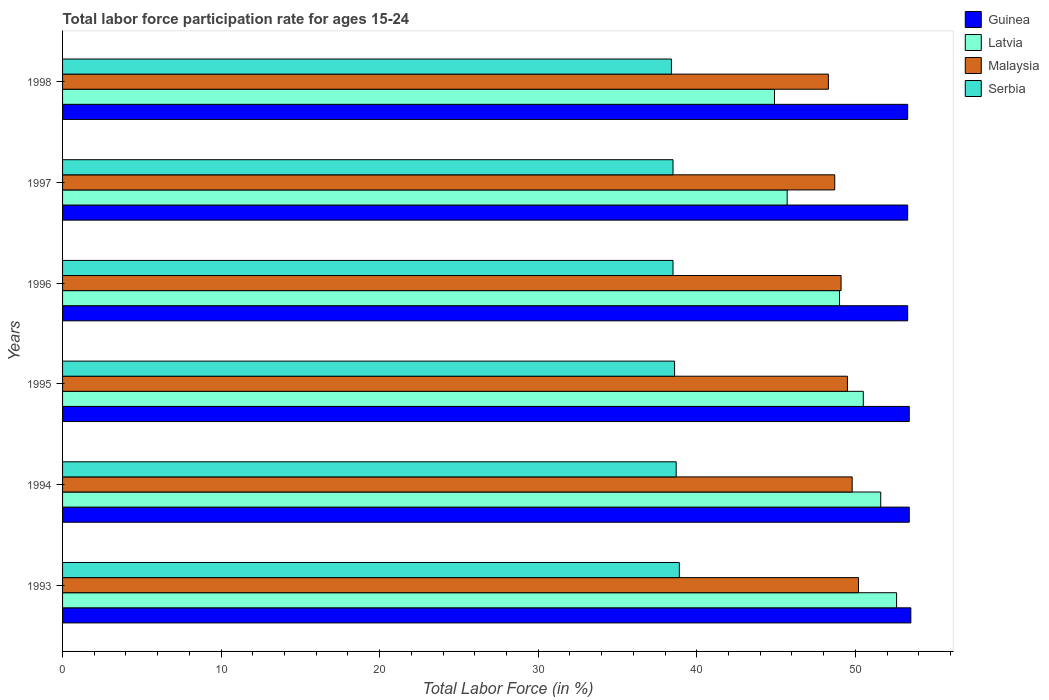How many different coloured bars are there?
Ensure brevity in your answer.  4. How many groups of bars are there?
Keep it short and to the point. 6. Are the number of bars per tick equal to the number of legend labels?
Your answer should be compact. Yes. What is the labor force participation rate in Malaysia in 1994?
Provide a succinct answer. 49.8. Across all years, what is the maximum labor force participation rate in Latvia?
Keep it short and to the point. 52.6. Across all years, what is the minimum labor force participation rate in Latvia?
Offer a terse response. 44.9. In which year was the labor force participation rate in Serbia maximum?
Offer a very short reply. 1993. What is the total labor force participation rate in Guinea in the graph?
Keep it short and to the point. 320.2. What is the difference between the labor force participation rate in Malaysia in 1993 and that in 1995?
Provide a short and direct response. 0.7. What is the difference between the labor force participation rate in Latvia in 1993 and the labor force participation rate in Serbia in 1996?
Make the answer very short. 14.1. What is the average labor force participation rate in Malaysia per year?
Provide a succinct answer. 49.27. In the year 1993, what is the difference between the labor force participation rate in Guinea and labor force participation rate in Latvia?
Your answer should be compact. 0.9. In how many years, is the labor force participation rate in Malaysia greater than 32 %?
Provide a succinct answer. 6. What is the ratio of the labor force participation rate in Malaysia in 1996 to that in 1997?
Keep it short and to the point. 1.01. Is the labor force participation rate in Serbia in 1994 less than that in 1996?
Your answer should be very brief. No. What is the difference between the highest and the second highest labor force participation rate in Guinea?
Provide a succinct answer. 0.1. What is the difference between the highest and the lowest labor force participation rate in Guinea?
Your response must be concise. 0.2. Is the sum of the labor force participation rate in Malaysia in 1995 and 1997 greater than the maximum labor force participation rate in Latvia across all years?
Offer a terse response. Yes. What does the 4th bar from the top in 1997 represents?
Provide a succinct answer. Guinea. What does the 1st bar from the bottom in 1996 represents?
Provide a short and direct response. Guinea. Is it the case that in every year, the sum of the labor force participation rate in Malaysia and labor force participation rate in Serbia is greater than the labor force participation rate in Guinea?
Provide a succinct answer. Yes. How many bars are there?
Your answer should be compact. 24. How many years are there in the graph?
Provide a succinct answer. 6. How many legend labels are there?
Provide a succinct answer. 4. How are the legend labels stacked?
Offer a very short reply. Vertical. What is the title of the graph?
Provide a succinct answer. Total labor force participation rate for ages 15-24. Does "Afghanistan" appear as one of the legend labels in the graph?
Your response must be concise. No. What is the label or title of the Y-axis?
Provide a short and direct response. Years. What is the Total Labor Force (in %) in Guinea in 1993?
Your answer should be compact. 53.5. What is the Total Labor Force (in %) of Latvia in 1993?
Keep it short and to the point. 52.6. What is the Total Labor Force (in %) in Malaysia in 1993?
Your response must be concise. 50.2. What is the Total Labor Force (in %) of Serbia in 1993?
Your answer should be very brief. 38.9. What is the Total Labor Force (in %) in Guinea in 1994?
Ensure brevity in your answer.  53.4. What is the Total Labor Force (in %) of Latvia in 1994?
Offer a very short reply. 51.6. What is the Total Labor Force (in %) of Malaysia in 1994?
Keep it short and to the point. 49.8. What is the Total Labor Force (in %) in Serbia in 1994?
Ensure brevity in your answer.  38.7. What is the Total Labor Force (in %) in Guinea in 1995?
Ensure brevity in your answer.  53.4. What is the Total Labor Force (in %) of Latvia in 1995?
Your answer should be very brief. 50.5. What is the Total Labor Force (in %) in Malaysia in 1995?
Offer a terse response. 49.5. What is the Total Labor Force (in %) of Serbia in 1995?
Provide a succinct answer. 38.6. What is the Total Labor Force (in %) of Guinea in 1996?
Your answer should be compact. 53.3. What is the Total Labor Force (in %) of Malaysia in 1996?
Your answer should be very brief. 49.1. What is the Total Labor Force (in %) of Serbia in 1996?
Your answer should be compact. 38.5. What is the Total Labor Force (in %) in Guinea in 1997?
Provide a succinct answer. 53.3. What is the Total Labor Force (in %) in Latvia in 1997?
Offer a terse response. 45.7. What is the Total Labor Force (in %) of Malaysia in 1997?
Make the answer very short. 48.7. What is the Total Labor Force (in %) in Serbia in 1997?
Offer a very short reply. 38.5. What is the Total Labor Force (in %) in Guinea in 1998?
Provide a succinct answer. 53.3. What is the Total Labor Force (in %) of Latvia in 1998?
Your answer should be very brief. 44.9. What is the Total Labor Force (in %) in Malaysia in 1998?
Your answer should be very brief. 48.3. What is the Total Labor Force (in %) of Serbia in 1998?
Ensure brevity in your answer.  38.4. Across all years, what is the maximum Total Labor Force (in %) in Guinea?
Your answer should be very brief. 53.5. Across all years, what is the maximum Total Labor Force (in %) of Latvia?
Offer a terse response. 52.6. Across all years, what is the maximum Total Labor Force (in %) in Malaysia?
Offer a very short reply. 50.2. Across all years, what is the maximum Total Labor Force (in %) in Serbia?
Offer a terse response. 38.9. Across all years, what is the minimum Total Labor Force (in %) of Guinea?
Your response must be concise. 53.3. Across all years, what is the minimum Total Labor Force (in %) of Latvia?
Your answer should be very brief. 44.9. Across all years, what is the minimum Total Labor Force (in %) of Malaysia?
Offer a terse response. 48.3. Across all years, what is the minimum Total Labor Force (in %) in Serbia?
Keep it short and to the point. 38.4. What is the total Total Labor Force (in %) in Guinea in the graph?
Provide a succinct answer. 320.2. What is the total Total Labor Force (in %) of Latvia in the graph?
Provide a short and direct response. 294.3. What is the total Total Labor Force (in %) in Malaysia in the graph?
Provide a succinct answer. 295.6. What is the total Total Labor Force (in %) of Serbia in the graph?
Offer a terse response. 231.6. What is the difference between the Total Labor Force (in %) of Guinea in 1993 and that in 1994?
Offer a very short reply. 0.1. What is the difference between the Total Labor Force (in %) of Latvia in 1993 and that in 1994?
Provide a short and direct response. 1. What is the difference between the Total Labor Force (in %) of Guinea in 1993 and that in 1995?
Provide a short and direct response. 0.1. What is the difference between the Total Labor Force (in %) in Latvia in 1993 and that in 1995?
Ensure brevity in your answer.  2.1. What is the difference between the Total Labor Force (in %) of Serbia in 1993 and that in 1995?
Make the answer very short. 0.3. What is the difference between the Total Labor Force (in %) in Latvia in 1993 and that in 1996?
Provide a short and direct response. 3.6. What is the difference between the Total Labor Force (in %) in Serbia in 1993 and that in 1996?
Offer a terse response. 0.4. What is the difference between the Total Labor Force (in %) of Latvia in 1993 and that in 1997?
Provide a short and direct response. 6.9. What is the difference between the Total Labor Force (in %) in Malaysia in 1993 and that in 1997?
Provide a short and direct response. 1.5. What is the difference between the Total Labor Force (in %) in Serbia in 1993 and that in 1997?
Make the answer very short. 0.4. What is the difference between the Total Labor Force (in %) of Guinea in 1993 and that in 1998?
Offer a terse response. 0.2. What is the difference between the Total Labor Force (in %) of Malaysia in 1993 and that in 1998?
Provide a short and direct response. 1.9. What is the difference between the Total Labor Force (in %) of Serbia in 1993 and that in 1998?
Ensure brevity in your answer.  0.5. What is the difference between the Total Labor Force (in %) in Guinea in 1994 and that in 1995?
Give a very brief answer. 0. What is the difference between the Total Labor Force (in %) in Guinea in 1994 and that in 1996?
Your answer should be very brief. 0.1. What is the difference between the Total Labor Force (in %) in Latvia in 1994 and that in 1996?
Your response must be concise. 2.6. What is the difference between the Total Labor Force (in %) of Malaysia in 1994 and that in 1996?
Offer a very short reply. 0.7. What is the difference between the Total Labor Force (in %) of Latvia in 1994 and that in 1997?
Offer a terse response. 5.9. What is the difference between the Total Labor Force (in %) in Malaysia in 1994 and that in 1998?
Provide a succinct answer. 1.5. What is the difference between the Total Labor Force (in %) of Serbia in 1994 and that in 1998?
Provide a short and direct response. 0.3. What is the difference between the Total Labor Force (in %) in Malaysia in 1995 and that in 1996?
Give a very brief answer. 0.4. What is the difference between the Total Labor Force (in %) in Guinea in 1995 and that in 1997?
Offer a very short reply. 0.1. What is the difference between the Total Labor Force (in %) in Latvia in 1995 and that in 1997?
Make the answer very short. 4.8. What is the difference between the Total Labor Force (in %) of Malaysia in 1995 and that in 1997?
Your response must be concise. 0.8. What is the difference between the Total Labor Force (in %) of Guinea in 1995 and that in 1998?
Offer a terse response. 0.1. What is the difference between the Total Labor Force (in %) in Guinea in 1996 and that in 1997?
Provide a succinct answer. 0. What is the difference between the Total Labor Force (in %) in Serbia in 1996 and that in 1997?
Provide a short and direct response. 0. What is the difference between the Total Labor Force (in %) of Latvia in 1996 and that in 1998?
Ensure brevity in your answer.  4.1. What is the difference between the Total Labor Force (in %) in Guinea in 1993 and the Total Labor Force (in %) in Malaysia in 1994?
Offer a terse response. 3.7. What is the difference between the Total Labor Force (in %) of Latvia in 1993 and the Total Labor Force (in %) of Malaysia in 1994?
Keep it short and to the point. 2.8. What is the difference between the Total Labor Force (in %) of Latvia in 1993 and the Total Labor Force (in %) of Serbia in 1994?
Give a very brief answer. 13.9. What is the difference between the Total Labor Force (in %) of Guinea in 1993 and the Total Labor Force (in %) of Latvia in 1995?
Offer a terse response. 3. What is the difference between the Total Labor Force (in %) of Latvia in 1993 and the Total Labor Force (in %) of Serbia in 1995?
Make the answer very short. 14. What is the difference between the Total Labor Force (in %) in Guinea in 1993 and the Total Labor Force (in %) in Serbia in 1996?
Ensure brevity in your answer.  15. What is the difference between the Total Labor Force (in %) of Latvia in 1993 and the Total Labor Force (in %) of Malaysia in 1996?
Provide a short and direct response. 3.5. What is the difference between the Total Labor Force (in %) in Guinea in 1993 and the Total Labor Force (in %) in Latvia in 1997?
Provide a short and direct response. 7.8. What is the difference between the Total Labor Force (in %) in Guinea in 1993 and the Total Labor Force (in %) in Malaysia in 1997?
Keep it short and to the point. 4.8. What is the difference between the Total Labor Force (in %) in Guinea in 1993 and the Total Labor Force (in %) in Serbia in 1997?
Offer a very short reply. 15. What is the difference between the Total Labor Force (in %) in Latvia in 1993 and the Total Labor Force (in %) in Malaysia in 1997?
Ensure brevity in your answer.  3.9. What is the difference between the Total Labor Force (in %) in Latvia in 1993 and the Total Labor Force (in %) in Serbia in 1997?
Your answer should be very brief. 14.1. What is the difference between the Total Labor Force (in %) of Latvia in 1994 and the Total Labor Force (in %) of Serbia in 1995?
Your answer should be compact. 13. What is the difference between the Total Labor Force (in %) in Guinea in 1994 and the Total Labor Force (in %) in Latvia in 1996?
Keep it short and to the point. 4.4. What is the difference between the Total Labor Force (in %) in Guinea in 1994 and the Total Labor Force (in %) in Malaysia in 1996?
Your response must be concise. 4.3. What is the difference between the Total Labor Force (in %) in Latvia in 1994 and the Total Labor Force (in %) in Malaysia in 1996?
Offer a terse response. 2.5. What is the difference between the Total Labor Force (in %) in Latvia in 1994 and the Total Labor Force (in %) in Serbia in 1996?
Your answer should be compact. 13.1. What is the difference between the Total Labor Force (in %) in Malaysia in 1994 and the Total Labor Force (in %) in Serbia in 1996?
Your response must be concise. 11.3. What is the difference between the Total Labor Force (in %) in Guinea in 1994 and the Total Labor Force (in %) in Latvia in 1997?
Offer a terse response. 7.7. What is the difference between the Total Labor Force (in %) of Guinea in 1994 and the Total Labor Force (in %) of Malaysia in 1997?
Offer a very short reply. 4.7. What is the difference between the Total Labor Force (in %) in Guinea in 1994 and the Total Labor Force (in %) in Serbia in 1997?
Provide a short and direct response. 14.9. What is the difference between the Total Labor Force (in %) in Malaysia in 1994 and the Total Labor Force (in %) in Serbia in 1997?
Offer a terse response. 11.3. What is the difference between the Total Labor Force (in %) of Guinea in 1994 and the Total Labor Force (in %) of Malaysia in 1998?
Provide a succinct answer. 5.1. What is the difference between the Total Labor Force (in %) in Guinea in 1994 and the Total Labor Force (in %) in Serbia in 1998?
Keep it short and to the point. 15. What is the difference between the Total Labor Force (in %) of Latvia in 1994 and the Total Labor Force (in %) of Malaysia in 1998?
Offer a terse response. 3.3. What is the difference between the Total Labor Force (in %) of Latvia in 1994 and the Total Labor Force (in %) of Serbia in 1998?
Ensure brevity in your answer.  13.2. What is the difference between the Total Labor Force (in %) in Malaysia in 1994 and the Total Labor Force (in %) in Serbia in 1998?
Keep it short and to the point. 11.4. What is the difference between the Total Labor Force (in %) in Guinea in 1995 and the Total Labor Force (in %) in Latvia in 1996?
Your answer should be very brief. 4.4. What is the difference between the Total Labor Force (in %) of Latvia in 1995 and the Total Labor Force (in %) of Serbia in 1996?
Offer a terse response. 12. What is the difference between the Total Labor Force (in %) in Malaysia in 1995 and the Total Labor Force (in %) in Serbia in 1996?
Provide a succinct answer. 11. What is the difference between the Total Labor Force (in %) of Guinea in 1995 and the Total Labor Force (in %) of Serbia in 1997?
Offer a very short reply. 14.9. What is the difference between the Total Labor Force (in %) of Malaysia in 1995 and the Total Labor Force (in %) of Serbia in 1997?
Keep it short and to the point. 11. What is the difference between the Total Labor Force (in %) in Latvia in 1995 and the Total Labor Force (in %) in Malaysia in 1998?
Keep it short and to the point. 2.2. What is the difference between the Total Labor Force (in %) of Latvia in 1995 and the Total Labor Force (in %) of Serbia in 1998?
Offer a very short reply. 12.1. What is the difference between the Total Labor Force (in %) in Guinea in 1996 and the Total Labor Force (in %) in Serbia in 1997?
Provide a succinct answer. 14.8. What is the difference between the Total Labor Force (in %) of Malaysia in 1996 and the Total Labor Force (in %) of Serbia in 1997?
Your answer should be very brief. 10.6. What is the difference between the Total Labor Force (in %) in Guinea in 1996 and the Total Labor Force (in %) in Latvia in 1998?
Provide a short and direct response. 8.4. What is the difference between the Total Labor Force (in %) in Latvia in 1996 and the Total Labor Force (in %) in Serbia in 1998?
Provide a succinct answer. 10.6. What is the difference between the Total Labor Force (in %) in Latvia in 1997 and the Total Labor Force (in %) in Serbia in 1998?
Offer a terse response. 7.3. What is the difference between the Total Labor Force (in %) in Malaysia in 1997 and the Total Labor Force (in %) in Serbia in 1998?
Give a very brief answer. 10.3. What is the average Total Labor Force (in %) of Guinea per year?
Make the answer very short. 53.37. What is the average Total Labor Force (in %) of Latvia per year?
Offer a terse response. 49.05. What is the average Total Labor Force (in %) in Malaysia per year?
Your answer should be compact. 49.27. What is the average Total Labor Force (in %) of Serbia per year?
Give a very brief answer. 38.6. In the year 1993, what is the difference between the Total Labor Force (in %) in Guinea and Total Labor Force (in %) in Malaysia?
Provide a short and direct response. 3.3. In the year 1993, what is the difference between the Total Labor Force (in %) in Latvia and Total Labor Force (in %) in Malaysia?
Offer a very short reply. 2.4. In the year 1993, what is the difference between the Total Labor Force (in %) of Latvia and Total Labor Force (in %) of Serbia?
Provide a short and direct response. 13.7. In the year 1993, what is the difference between the Total Labor Force (in %) in Malaysia and Total Labor Force (in %) in Serbia?
Your answer should be compact. 11.3. In the year 1994, what is the difference between the Total Labor Force (in %) in Guinea and Total Labor Force (in %) in Malaysia?
Offer a terse response. 3.6. In the year 1994, what is the difference between the Total Labor Force (in %) of Latvia and Total Labor Force (in %) of Malaysia?
Provide a succinct answer. 1.8. In the year 1994, what is the difference between the Total Labor Force (in %) of Malaysia and Total Labor Force (in %) of Serbia?
Give a very brief answer. 11.1. In the year 1995, what is the difference between the Total Labor Force (in %) of Guinea and Total Labor Force (in %) of Latvia?
Provide a succinct answer. 2.9. In the year 1995, what is the difference between the Total Labor Force (in %) of Guinea and Total Labor Force (in %) of Serbia?
Provide a succinct answer. 14.8. In the year 1995, what is the difference between the Total Labor Force (in %) of Latvia and Total Labor Force (in %) of Malaysia?
Ensure brevity in your answer.  1. In the year 1995, what is the difference between the Total Labor Force (in %) of Malaysia and Total Labor Force (in %) of Serbia?
Provide a short and direct response. 10.9. In the year 1996, what is the difference between the Total Labor Force (in %) of Guinea and Total Labor Force (in %) of Malaysia?
Offer a very short reply. 4.2. In the year 1996, what is the difference between the Total Labor Force (in %) of Guinea and Total Labor Force (in %) of Serbia?
Your answer should be very brief. 14.8. In the year 1996, what is the difference between the Total Labor Force (in %) of Latvia and Total Labor Force (in %) of Malaysia?
Make the answer very short. -0.1. In the year 1996, what is the difference between the Total Labor Force (in %) in Latvia and Total Labor Force (in %) in Serbia?
Your answer should be very brief. 10.5. In the year 1997, what is the difference between the Total Labor Force (in %) of Guinea and Total Labor Force (in %) of Malaysia?
Provide a short and direct response. 4.6. In the year 1997, what is the difference between the Total Labor Force (in %) of Guinea and Total Labor Force (in %) of Serbia?
Provide a short and direct response. 14.8. In the year 1997, what is the difference between the Total Labor Force (in %) of Malaysia and Total Labor Force (in %) of Serbia?
Give a very brief answer. 10.2. In the year 1998, what is the difference between the Total Labor Force (in %) in Guinea and Total Labor Force (in %) in Serbia?
Provide a succinct answer. 14.9. In the year 1998, what is the difference between the Total Labor Force (in %) in Malaysia and Total Labor Force (in %) in Serbia?
Ensure brevity in your answer.  9.9. What is the ratio of the Total Labor Force (in %) of Latvia in 1993 to that in 1994?
Give a very brief answer. 1.02. What is the ratio of the Total Labor Force (in %) in Malaysia in 1993 to that in 1994?
Provide a short and direct response. 1.01. What is the ratio of the Total Labor Force (in %) in Latvia in 1993 to that in 1995?
Offer a terse response. 1.04. What is the ratio of the Total Labor Force (in %) of Malaysia in 1993 to that in 1995?
Your answer should be compact. 1.01. What is the ratio of the Total Labor Force (in %) in Guinea in 1993 to that in 1996?
Ensure brevity in your answer.  1. What is the ratio of the Total Labor Force (in %) of Latvia in 1993 to that in 1996?
Your answer should be compact. 1.07. What is the ratio of the Total Labor Force (in %) of Malaysia in 1993 to that in 1996?
Ensure brevity in your answer.  1.02. What is the ratio of the Total Labor Force (in %) in Serbia in 1993 to that in 1996?
Ensure brevity in your answer.  1.01. What is the ratio of the Total Labor Force (in %) in Guinea in 1993 to that in 1997?
Provide a succinct answer. 1. What is the ratio of the Total Labor Force (in %) of Latvia in 1993 to that in 1997?
Provide a succinct answer. 1.15. What is the ratio of the Total Labor Force (in %) in Malaysia in 1993 to that in 1997?
Your answer should be compact. 1.03. What is the ratio of the Total Labor Force (in %) of Serbia in 1993 to that in 1997?
Ensure brevity in your answer.  1.01. What is the ratio of the Total Labor Force (in %) of Guinea in 1993 to that in 1998?
Provide a short and direct response. 1. What is the ratio of the Total Labor Force (in %) of Latvia in 1993 to that in 1998?
Keep it short and to the point. 1.17. What is the ratio of the Total Labor Force (in %) in Malaysia in 1993 to that in 1998?
Ensure brevity in your answer.  1.04. What is the ratio of the Total Labor Force (in %) of Serbia in 1993 to that in 1998?
Make the answer very short. 1.01. What is the ratio of the Total Labor Force (in %) of Guinea in 1994 to that in 1995?
Your answer should be compact. 1. What is the ratio of the Total Labor Force (in %) in Latvia in 1994 to that in 1995?
Offer a very short reply. 1.02. What is the ratio of the Total Labor Force (in %) of Latvia in 1994 to that in 1996?
Your answer should be very brief. 1.05. What is the ratio of the Total Labor Force (in %) of Malaysia in 1994 to that in 1996?
Offer a very short reply. 1.01. What is the ratio of the Total Labor Force (in %) in Latvia in 1994 to that in 1997?
Make the answer very short. 1.13. What is the ratio of the Total Labor Force (in %) in Malaysia in 1994 to that in 1997?
Make the answer very short. 1.02. What is the ratio of the Total Labor Force (in %) in Serbia in 1994 to that in 1997?
Offer a very short reply. 1.01. What is the ratio of the Total Labor Force (in %) of Guinea in 1994 to that in 1998?
Offer a terse response. 1. What is the ratio of the Total Labor Force (in %) in Latvia in 1994 to that in 1998?
Give a very brief answer. 1.15. What is the ratio of the Total Labor Force (in %) in Malaysia in 1994 to that in 1998?
Offer a very short reply. 1.03. What is the ratio of the Total Labor Force (in %) of Latvia in 1995 to that in 1996?
Your answer should be very brief. 1.03. What is the ratio of the Total Labor Force (in %) of Malaysia in 1995 to that in 1996?
Keep it short and to the point. 1.01. What is the ratio of the Total Labor Force (in %) of Serbia in 1995 to that in 1996?
Make the answer very short. 1. What is the ratio of the Total Labor Force (in %) in Guinea in 1995 to that in 1997?
Provide a short and direct response. 1. What is the ratio of the Total Labor Force (in %) in Latvia in 1995 to that in 1997?
Provide a succinct answer. 1.1. What is the ratio of the Total Labor Force (in %) in Malaysia in 1995 to that in 1997?
Your answer should be compact. 1.02. What is the ratio of the Total Labor Force (in %) of Guinea in 1995 to that in 1998?
Keep it short and to the point. 1. What is the ratio of the Total Labor Force (in %) in Latvia in 1995 to that in 1998?
Keep it short and to the point. 1.12. What is the ratio of the Total Labor Force (in %) of Malaysia in 1995 to that in 1998?
Ensure brevity in your answer.  1.02. What is the ratio of the Total Labor Force (in %) in Serbia in 1995 to that in 1998?
Your answer should be very brief. 1.01. What is the ratio of the Total Labor Force (in %) in Latvia in 1996 to that in 1997?
Keep it short and to the point. 1.07. What is the ratio of the Total Labor Force (in %) in Malaysia in 1996 to that in 1997?
Keep it short and to the point. 1.01. What is the ratio of the Total Labor Force (in %) of Serbia in 1996 to that in 1997?
Provide a succinct answer. 1. What is the ratio of the Total Labor Force (in %) in Guinea in 1996 to that in 1998?
Your answer should be very brief. 1. What is the ratio of the Total Labor Force (in %) in Latvia in 1996 to that in 1998?
Offer a very short reply. 1.09. What is the ratio of the Total Labor Force (in %) of Malaysia in 1996 to that in 1998?
Your answer should be very brief. 1.02. What is the ratio of the Total Labor Force (in %) of Latvia in 1997 to that in 1998?
Give a very brief answer. 1.02. What is the ratio of the Total Labor Force (in %) of Malaysia in 1997 to that in 1998?
Ensure brevity in your answer.  1.01. What is the ratio of the Total Labor Force (in %) of Serbia in 1997 to that in 1998?
Provide a succinct answer. 1. What is the difference between the highest and the second highest Total Labor Force (in %) in Guinea?
Your response must be concise. 0.1. What is the difference between the highest and the second highest Total Labor Force (in %) in Serbia?
Make the answer very short. 0.2. What is the difference between the highest and the lowest Total Labor Force (in %) in Guinea?
Provide a succinct answer. 0.2. What is the difference between the highest and the lowest Total Labor Force (in %) of Malaysia?
Offer a terse response. 1.9. 